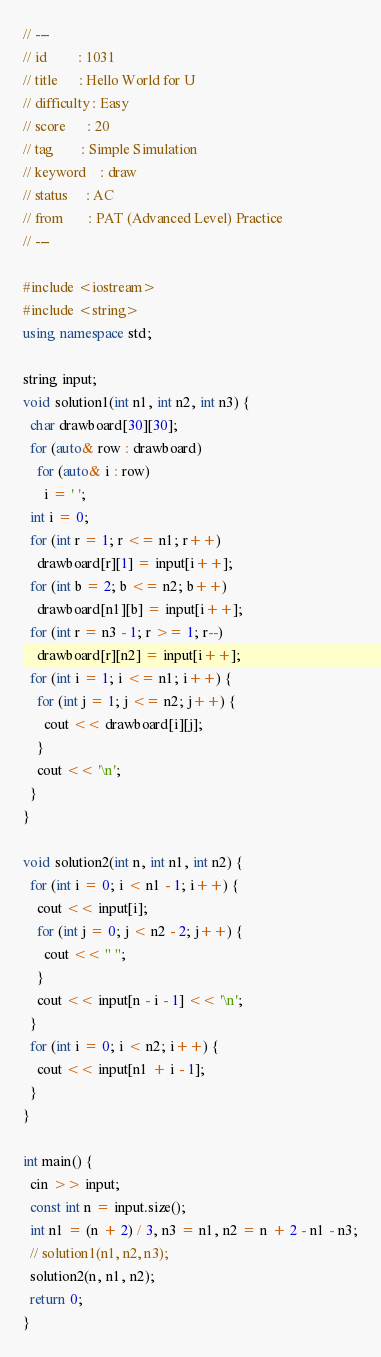<code> <loc_0><loc_0><loc_500><loc_500><_C++_>// ---
// id         : 1031
// title      : Hello World for U
// difficulty : Easy
// score      : 20
// tag        : Simple Simulation
// keyword    : draw
// status     : AC
// from       : PAT (Advanced Level) Practice
// ---

#include <iostream>
#include <string>
using namespace std;

string input;
void solution1(int n1, int n2, int n3) {
  char drawboard[30][30];
  for (auto& row : drawboard)
    for (auto& i : row)
      i = ' ';
  int i = 0;
  for (int r = 1; r <= n1; r++)
    drawboard[r][1] = input[i++];
  for (int b = 2; b <= n2; b++)
    drawboard[n1][b] = input[i++];
  for (int r = n3 - 1; r >= 1; r--)
    drawboard[r][n2] = input[i++];
  for (int i = 1; i <= n1; i++) {
    for (int j = 1; j <= n2; j++) {
      cout << drawboard[i][j];
    }
    cout << '\n';
  }
}

void solution2(int n, int n1, int n2) {
  for (int i = 0; i < n1 - 1; i++) {
    cout << input[i];
    for (int j = 0; j < n2 - 2; j++) {
      cout << " ";
    }
    cout << input[n - i - 1] << '\n';
  }
  for (int i = 0; i < n2; i++) {
    cout << input[n1 + i - 1];
  }
}

int main() {
  cin >> input;
  const int n = input.size();
  int n1 = (n + 2) / 3, n3 = n1, n2 = n + 2 - n1 - n3;
  // solution1(n1, n2, n3);
  solution2(n, n1, n2);
  return 0;
}</code> 